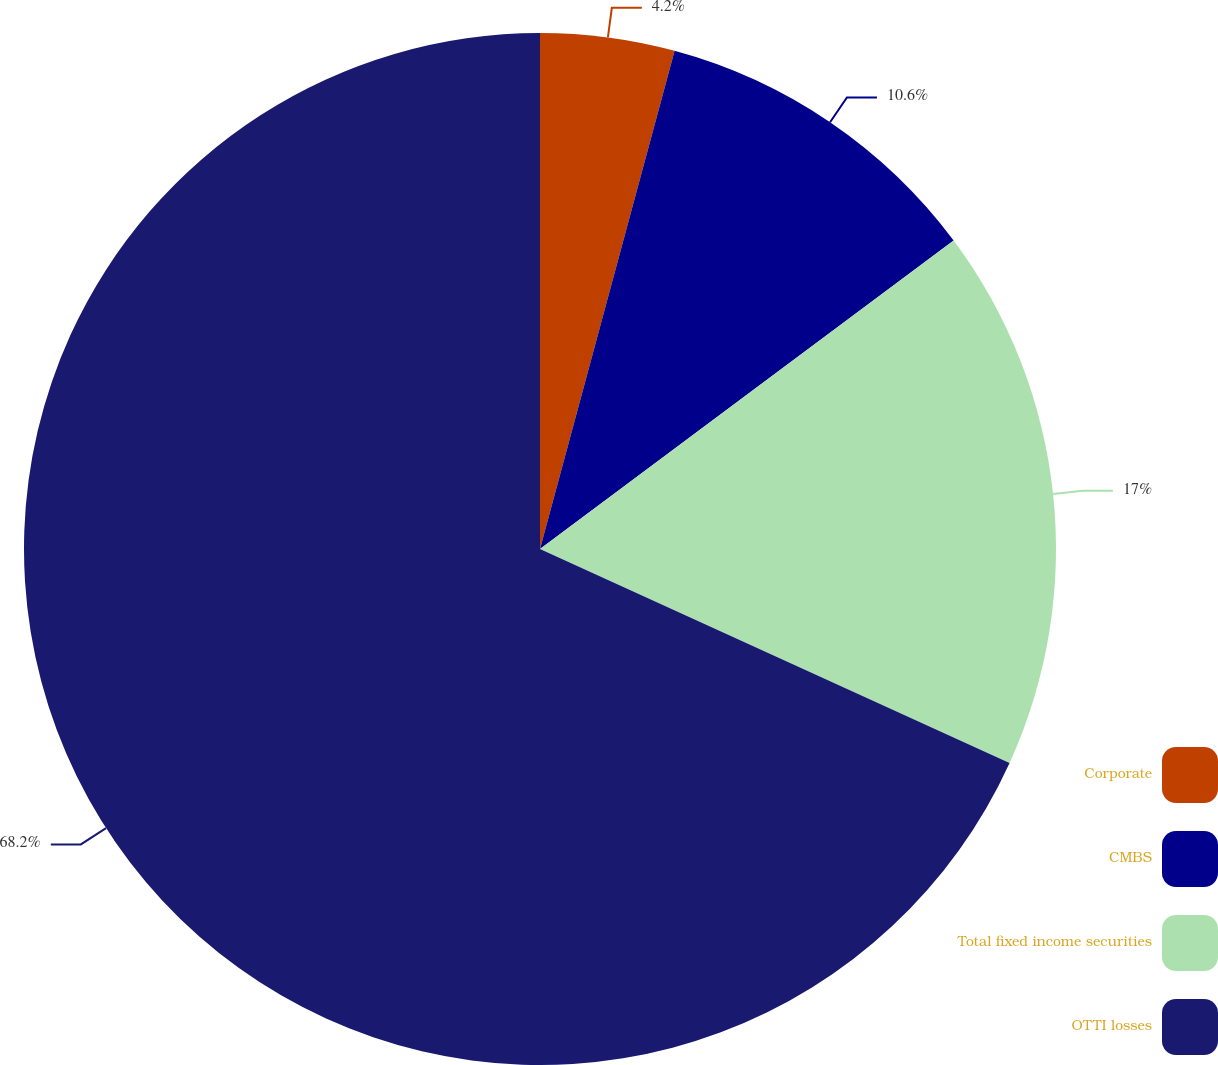Convert chart. <chart><loc_0><loc_0><loc_500><loc_500><pie_chart><fcel>Corporate<fcel>CMBS<fcel>Total fixed income securities<fcel>OTTI losses<nl><fcel>4.2%<fcel>10.6%<fcel>17.0%<fcel>68.19%<nl></chart> 